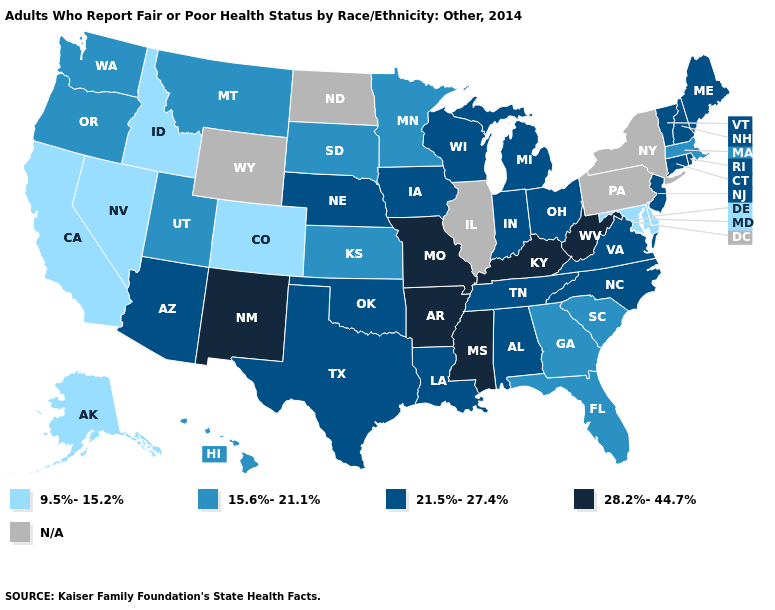What is the highest value in the USA?
Short answer required. 28.2%-44.7%. What is the value of Wyoming?
Short answer required. N/A. Among the states that border Washington , does Oregon have the lowest value?
Quick response, please. No. Name the states that have a value in the range 9.5%-15.2%?
Concise answer only. Alaska, California, Colorado, Delaware, Idaho, Maryland, Nevada. What is the highest value in the USA?
Short answer required. 28.2%-44.7%. What is the value of Kansas?
Answer briefly. 15.6%-21.1%. Name the states that have a value in the range N/A?
Keep it brief. Illinois, New York, North Dakota, Pennsylvania, Wyoming. Does Delaware have the lowest value in the South?
Be succinct. Yes. Is the legend a continuous bar?
Concise answer only. No. Name the states that have a value in the range 28.2%-44.7%?
Write a very short answer. Arkansas, Kentucky, Mississippi, Missouri, New Mexico, West Virginia. Does Missouri have the highest value in the MidWest?
Be succinct. Yes. What is the lowest value in the MidWest?
Concise answer only. 15.6%-21.1%. Is the legend a continuous bar?
Keep it brief. No. Among the states that border Colorado , does Arizona have the highest value?
Give a very brief answer. No. Name the states that have a value in the range 15.6%-21.1%?
Give a very brief answer. Florida, Georgia, Hawaii, Kansas, Massachusetts, Minnesota, Montana, Oregon, South Carolina, South Dakota, Utah, Washington. 